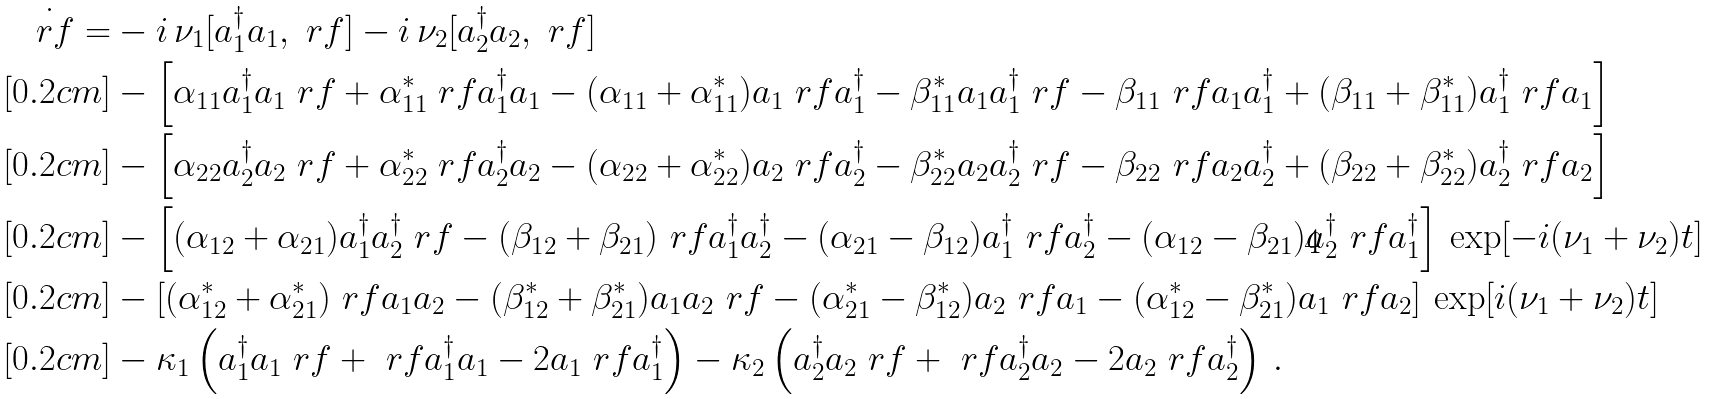<formula> <loc_0><loc_0><loc_500><loc_500>\dot { \ r f } = & - i \, \nu _ { 1 } [ a _ { 1 } ^ { \dagger } a _ { 1 } , \ r f ] - i \, \nu _ { 2 } [ a _ { 2 } ^ { \dagger } a _ { 2 } , \ r f ] \\ [ 0 . 2 c m ] & - \left [ \alpha _ { 1 1 } a _ { 1 } ^ { \dagger } a _ { 1 } \ r f + \alpha _ { 1 1 } ^ { * } \ r f a _ { 1 } ^ { \dagger } a _ { 1 } - ( \alpha _ { 1 1 } + \alpha _ { 1 1 } ^ { * } ) a _ { 1 } \ r f a _ { 1 } ^ { \dagger } - \beta _ { 1 1 } ^ { * } a _ { 1 } a _ { 1 } ^ { \dagger } \ r f - \beta _ { 1 1 } \ r f a _ { 1 } a _ { 1 } ^ { \dagger } + ( \beta _ { 1 1 } + \beta _ { 1 1 } ^ { * } ) a _ { 1 } ^ { \dagger } \ r f a _ { 1 } \right ] \\ [ 0 . 2 c m ] & - \left [ \alpha _ { 2 2 } a _ { 2 } ^ { \dagger } a _ { 2 } \ r f + \alpha _ { 2 2 } ^ { * } \ r f a _ { 2 } ^ { \dagger } a _ { 2 } - ( \alpha _ { 2 2 } + \alpha _ { 2 2 } ^ { * } ) a _ { 2 } \ r f a _ { 2 } ^ { \dagger } - \beta _ { 2 2 } ^ { * } a _ { 2 } a _ { 2 } ^ { \dagger } \ r f - \beta _ { 2 2 } \ r f a _ { 2 } a _ { 2 } ^ { \dagger } + ( \beta _ { 2 2 } + \beta _ { 2 2 } ^ { * } ) a _ { 2 } ^ { \dagger } \ r f a _ { 2 } \right ] \\ [ 0 . 2 c m ] & - \left [ ( \alpha _ { 1 2 } + \alpha _ { 2 1 } ) a _ { 1 } ^ { \dagger } a _ { 2 } ^ { \dagger } \ r f - ( \beta _ { 1 2 } + \beta _ { 2 1 } ) \ r f a _ { 1 } ^ { \dagger } a _ { 2 } ^ { \dagger } - ( \alpha _ { 2 1 } - \beta _ { 1 2 } ) a _ { 1 } ^ { \dagger } \ r f a _ { 2 } ^ { \dagger } - ( \alpha _ { 1 2 } - \beta _ { 2 1 } ) a _ { 2 } ^ { \dagger } \ r f a _ { 1 } ^ { \dagger } \right ] \, \exp [ - i ( \nu _ { 1 } + \nu _ { 2 } ) t ] \\ [ 0 . 2 c m ] & - \left [ ( \alpha _ { 1 2 } ^ { * } + \alpha _ { 2 1 } ^ { * } ) \ r f a _ { 1 } a _ { 2 } - ( \beta _ { 1 2 } ^ { * } + \beta _ { 2 1 } ^ { * } ) a _ { 1 } a _ { 2 } \ r f - ( \alpha _ { 2 1 } ^ { * } - \beta _ { 1 2 } ^ { * } ) a _ { 2 } \ r f a _ { 1 } - ( \alpha _ { 1 2 } ^ { * } - \beta _ { 2 1 } ^ { * } ) a _ { 1 } \ r f a _ { 2 } \right ] \, \exp [ i ( \nu _ { 1 } + \nu _ { 2 } ) t ] \\ [ 0 . 2 c m ] & - \kappa _ { 1 } \left ( a _ { 1 } ^ { \dagger } a _ { 1 } \ r f + \ r f a _ { 1 } ^ { \dagger } a _ { 1 } - 2 a _ { 1 } \ r f a _ { 1 } ^ { \dagger } \right ) - \kappa _ { 2 } \left ( a _ { 2 } ^ { \dagger } a _ { 2 } \ r f + \ r f a _ { 2 } ^ { \dagger } a _ { 2 } - 2 a _ { 2 } \ r f a _ { 2 } ^ { \dagger } \right ) \, .</formula> 